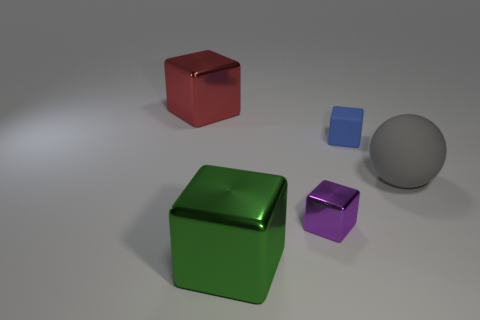What number of objects are small objects to the right of the purple thing or big matte objects?
Offer a very short reply. 2. Is the tiny purple cube made of the same material as the big thing on the left side of the green object?
Offer a very short reply. Yes. There is a object that is to the left of the green cube in front of the large gray rubber thing; what is its shape?
Give a very brief answer. Cube. Does the big matte ball have the same color as the large shiny thing that is behind the big green shiny thing?
Provide a succinct answer. No. Is there any other thing that has the same material as the big gray ball?
Make the answer very short. Yes. There is a big red metal thing; what shape is it?
Provide a succinct answer. Cube. What size is the matte thing to the left of the big thing right of the big green shiny cube?
Offer a very short reply. Small. Are there an equal number of matte things in front of the tiny purple cube and big rubber things to the left of the big green shiny thing?
Offer a very short reply. Yes. There is a thing that is to the right of the purple shiny thing and behind the ball; what is its material?
Make the answer very short. Rubber. There is a blue matte block; is its size the same as the shiny block that is to the right of the large green shiny object?
Ensure brevity in your answer.  Yes. 